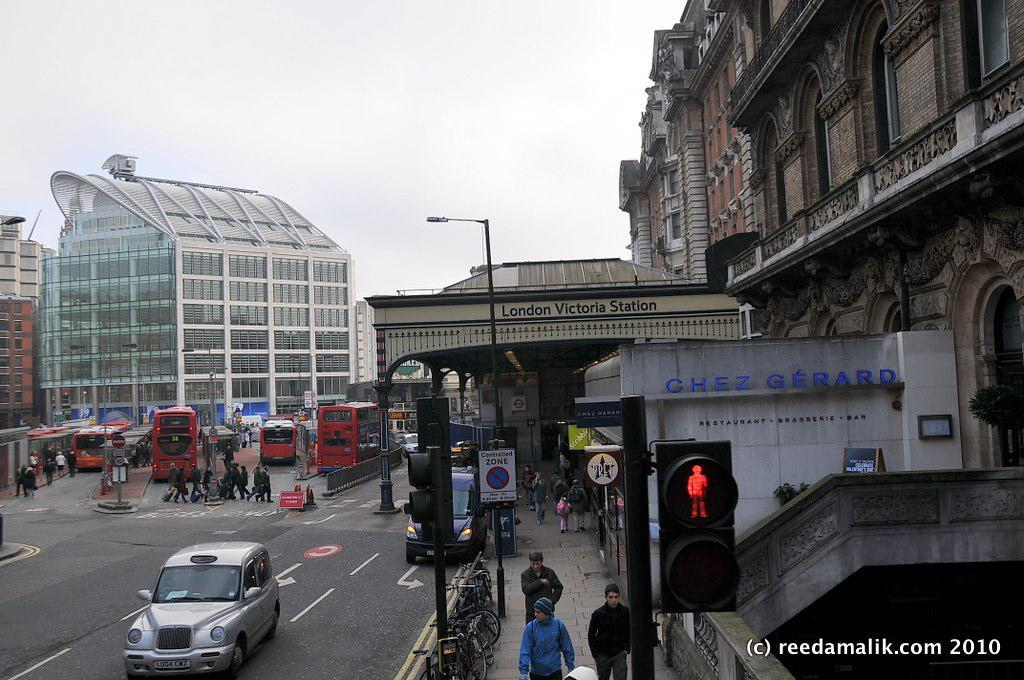Provide a one-sentence caption for the provided image. A group of people are walking down a sidewalk by a building that says Chez Gerard. 